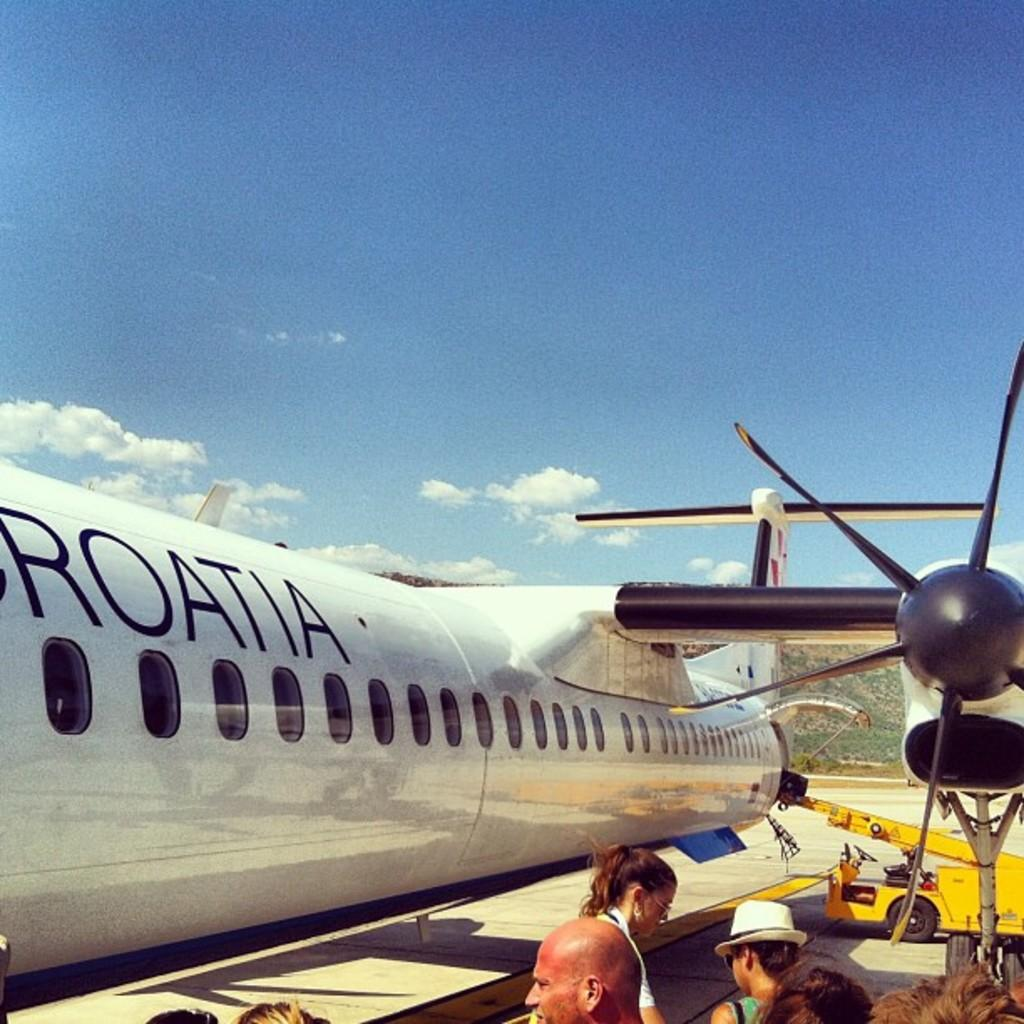Provide a one-sentence caption for the provided image. people waiting to board a white croatia plane. 